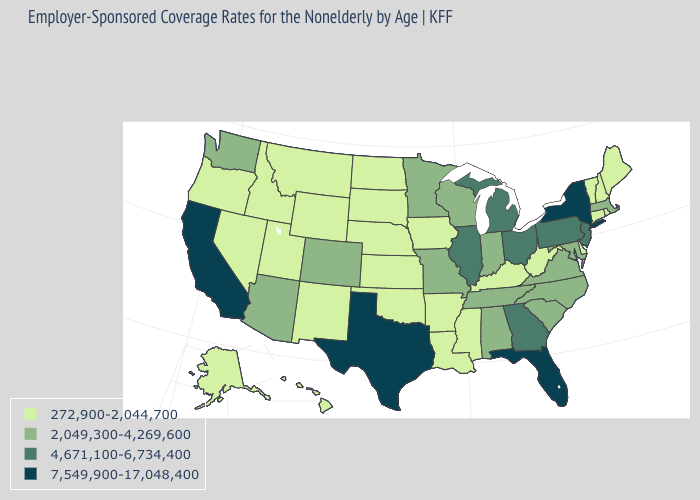What is the lowest value in states that border New Jersey?
Concise answer only. 272,900-2,044,700. What is the value of Hawaii?
Answer briefly. 272,900-2,044,700. What is the value of Wisconsin?
Concise answer only. 2,049,300-4,269,600. What is the value of Iowa?
Give a very brief answer. 272,900-2,044,700. Among the states that border Alabama , which have the lowest value?
Short answer required. Mississippi. Name the states that have a value in the range 7,549,900-17,048,400?
Give a very brief answer. California, Florida, New York, Texas. Does South Carolina have the lowest value in the South?
Be succinct. No. What is the value of Tennessee?
Answer briefly. 2,049,300-4,269,600. What is the lowest value in the USA?
Short answer required. 272,900-2,044,700. What is the value of Arkansas?
Quick response, please. 272,900-2,044,700. What is the highest value in the USA?
Short answer required. 7,549,900-17,048,400. What is the lowest value in the USA?
Quick response, please. 272,900-2,044,700. Is the legend a continuous bar?
Quick response, please. No. What is the value of Rhode Island?
Be succinct. 272,900-2,044,700. Does the first symbol in the legend represent the smallest category?
Quick response, please. Yes. 